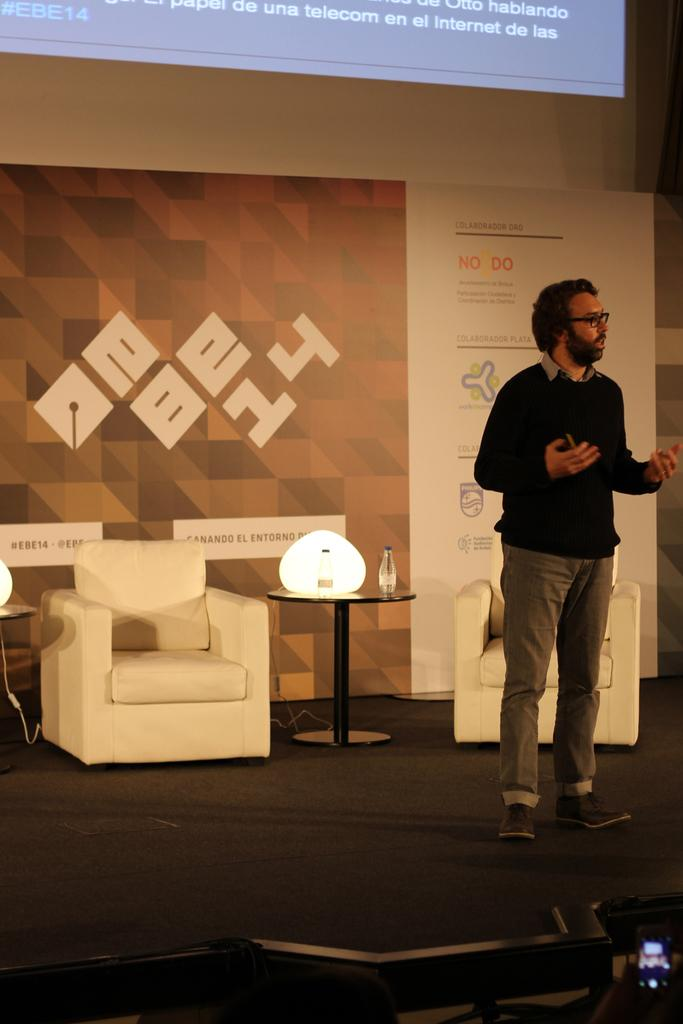What is the main subject of the image? There is a man in the image. What is the man doing in the image? The man is standing. What objects can be seen in the background of the image? There is a table and a chair in the background of the image. What is on the table in the image? There is a bottle on the table. How many fangs can be seen on the man in the image? There are no fangs visible on the man in the image, as humans do not have fangs. What type of dogs are present in the image? There are no dogs present in the image; it features a man standing with a table and a chair in the background. 